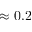<formula> <loc_0><loc_0><loc_500><loc_500>\approx 0 . 2</formula> 